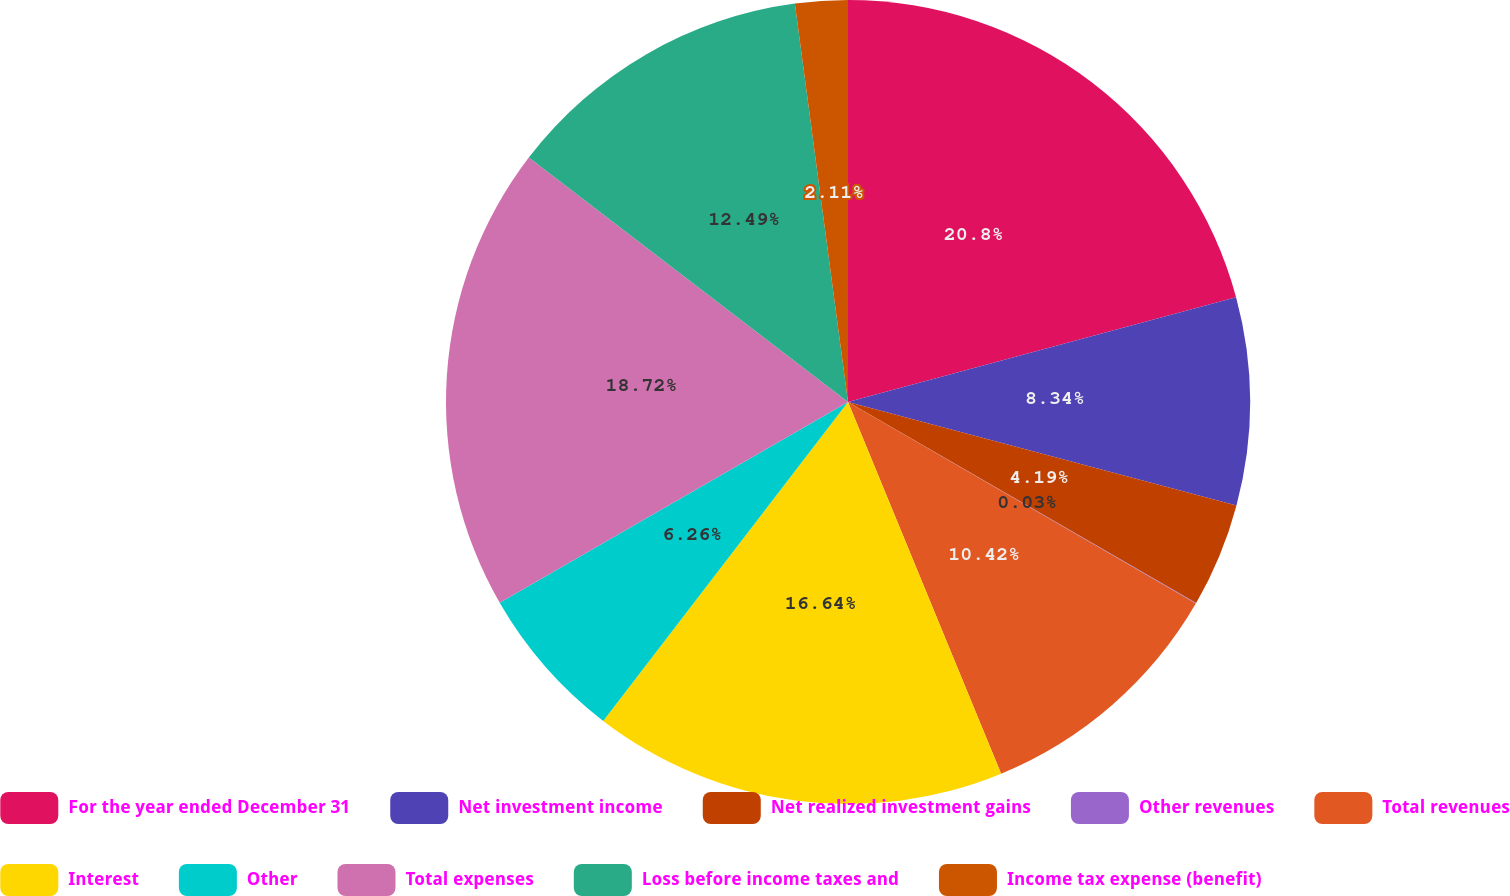Convert chart. <chart><loc_0><loc_0><loc_500><loc_500><pie_chart><fcel>For the year ended December 31<fcel>Net investment income<fcel>Net realized investment gains<fcel>Other revenues<fcel>Total revenues<fcel>Interest<fcel>Other<fcel>Total expenses<fcel>Loss before income taxes and<fcel>Income tax expense (benefit)<nl><fcel>20.8%<fcel>8.34%<fcel>4.19%<fcel>0.03%<fcel>10.42%<fcel>16.64%<fcel>6.26%<fcel>18.72%<fcel>12.49%<fcel>2.11%<nl></chart> 